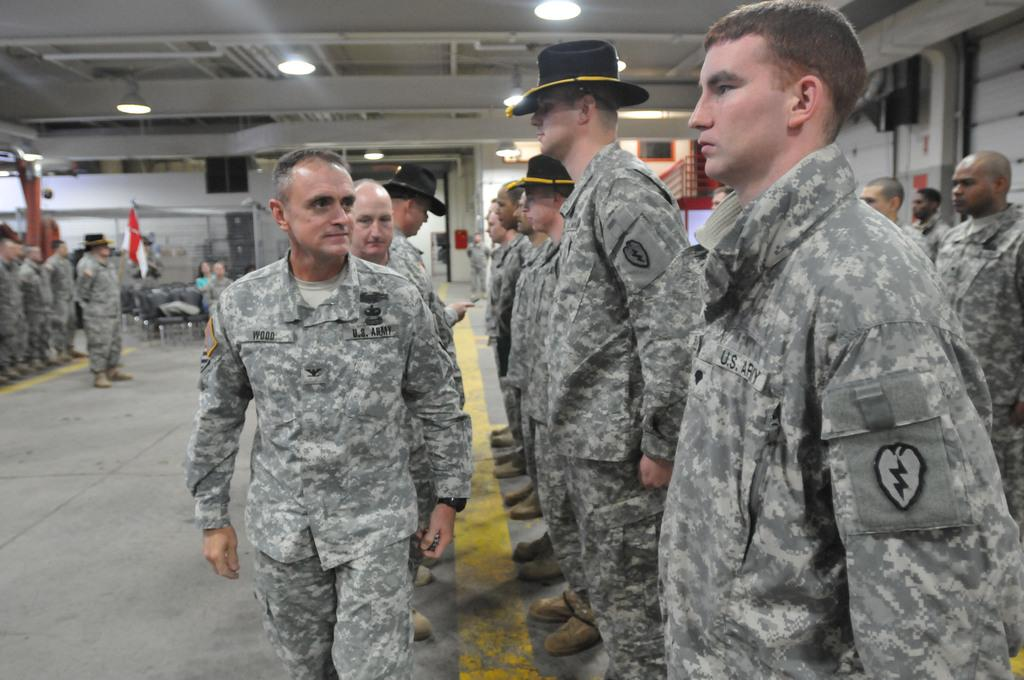What are the people in the image doing? There is a group of people on the floor in the image. What type of furniture is present in the image? There are chairs in the image. What can be seen illuminating the scene? There are lights in the image. What symbol or emblem is visible in the image? There is a flag in the image. What is visible in the background of the image? There is a wall in the background of the image. What type of bun is being used to hold the tin in the image? There is no bun or tin present in the image. How many tomatoes are visible on the wall in the image? There are no tomatoes visible on the wall in the image. 